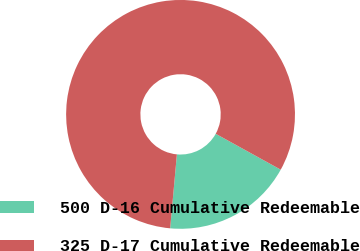<chart> <loc_0><loc_0><loc_500><loc_500><pie_chart><fcel>500 D-16 Cumulative Redeemable<fcel>325 D-17 Cumulative Redeemable<nl><fcel>18.42%<fcel>81.58%<nl></chart> 